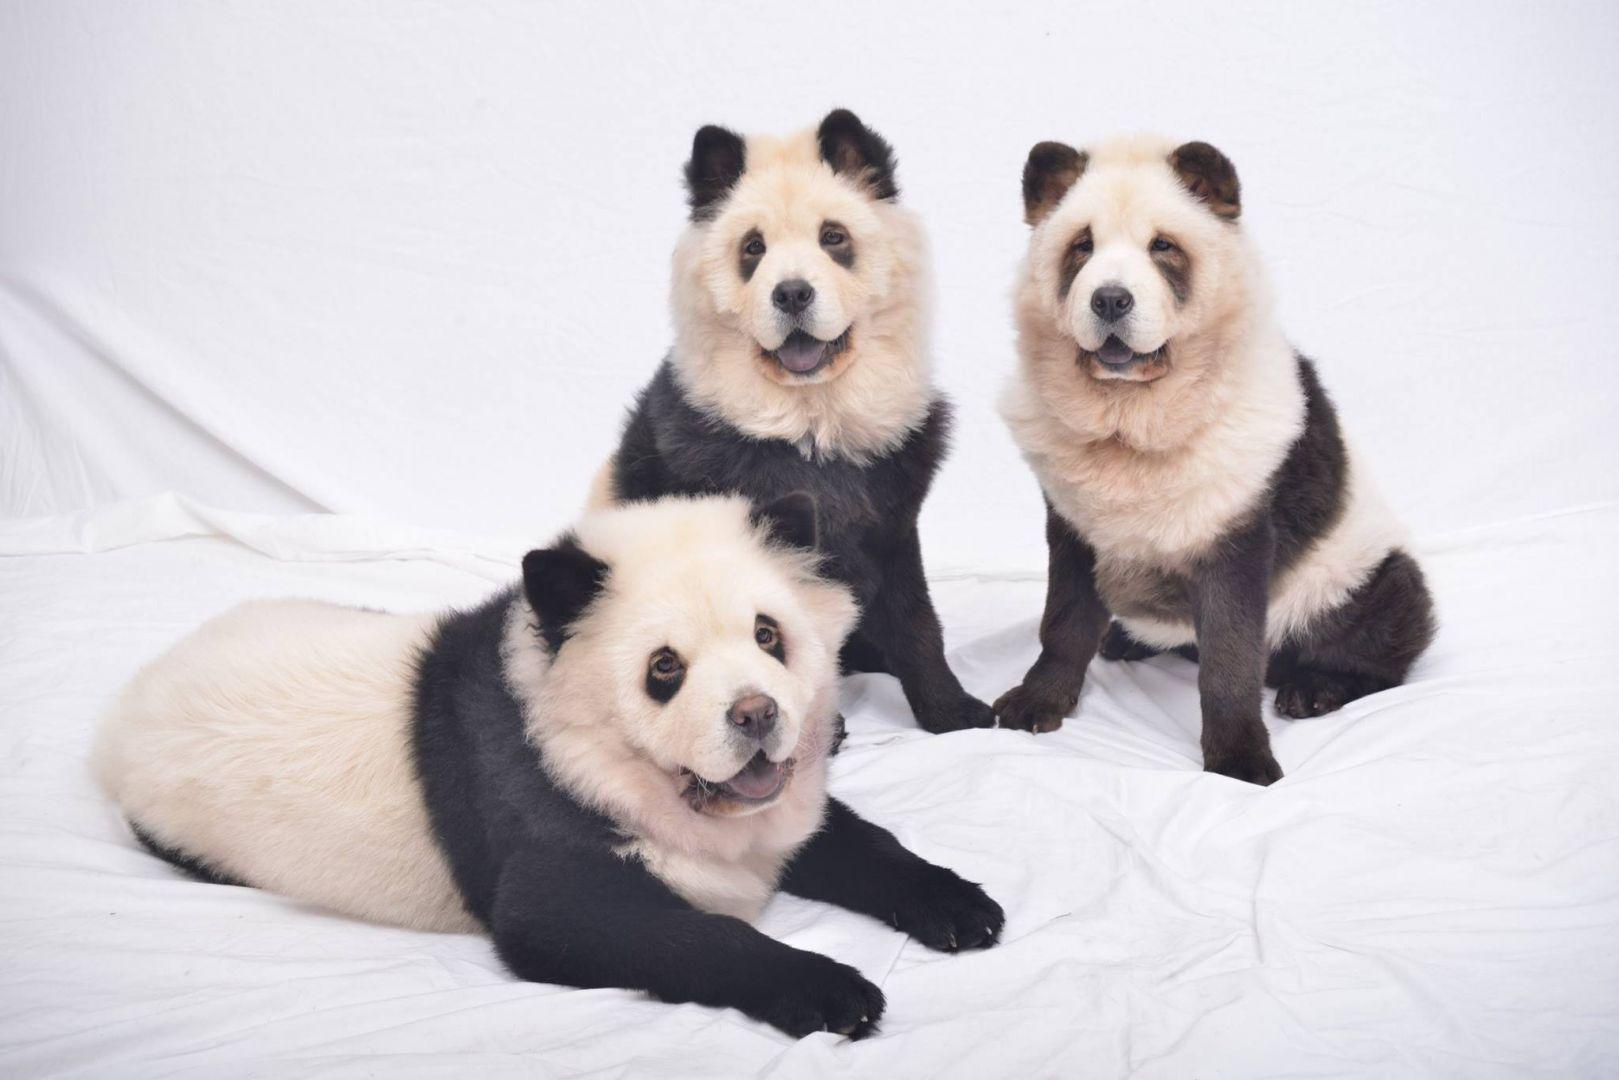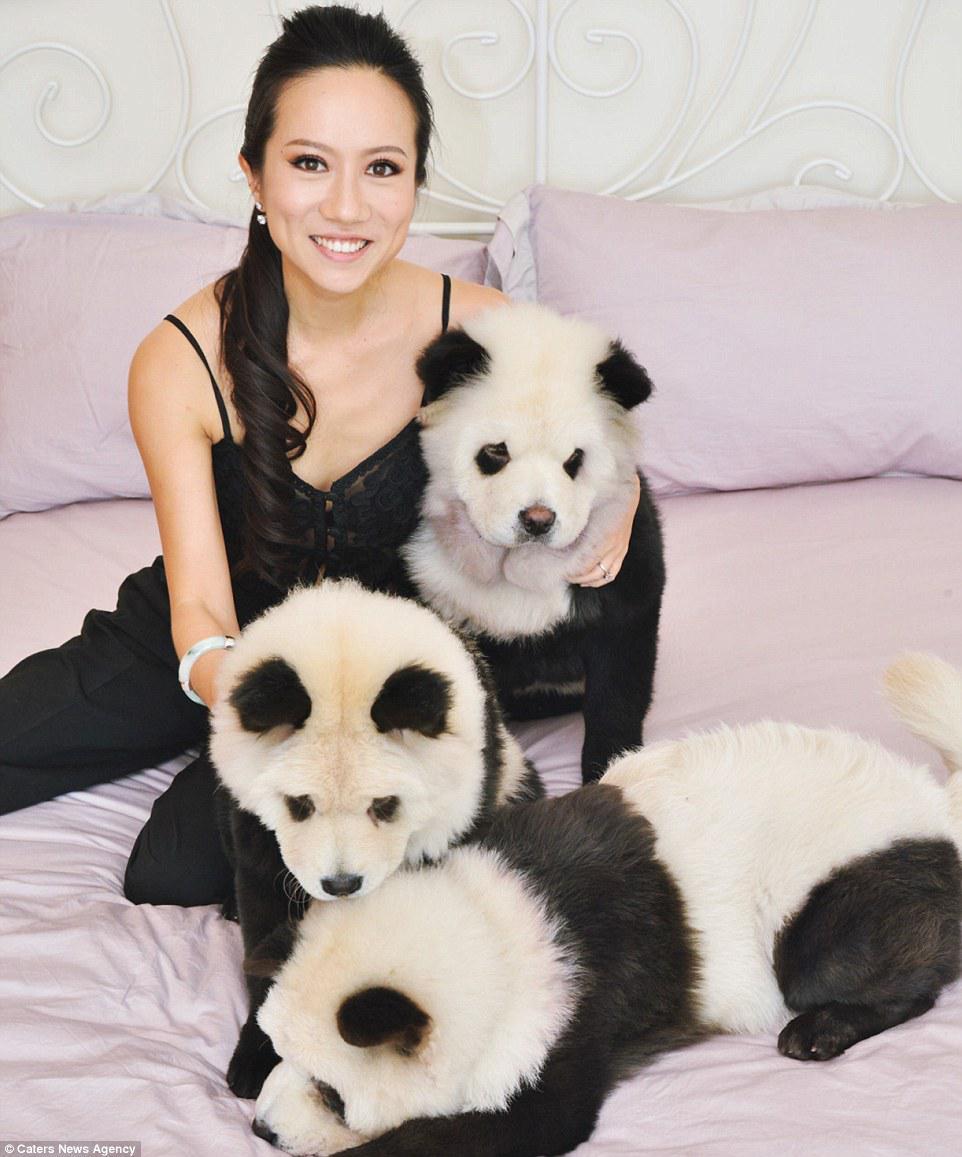The first image is the image on the left, the second image is the image on the right. Given the left and right images, does the statement "There is at least one cream colored Chow Chow puppy in the image on the left." hold true? Answer yes or no. No. The first image is the image on the left, the second image is the image on the right. For the images displayed, is the sentence "In one image, a woman poses with three dogs" factually correct? Answer yes or no. Yes. 